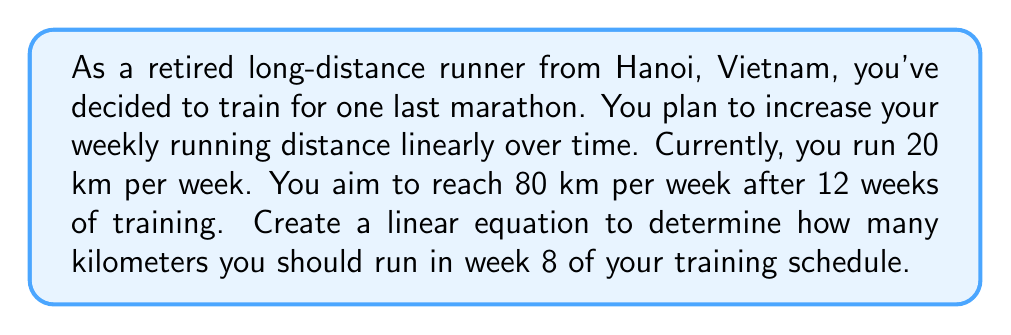Give your solution to this math problem. Let's approach this step-by-step using a linear equation:

1) First, let's define our variables:
   $x$ = number of weeks
   $y$ = distance run in km per week

2) We know two points on this line:
   At week 0: $(0, 20)$
   At week 12: $(12, 80)$

3) We can use the point-slope form of a linear equation:
   $y - y_1 = m(x - x_1)$

4) Calculate the slope $(m)$:
   $m = \frac{y_2 - y_1}{x_2 - x_1} = \frac{80 - 20}{12 - 0} = \frac{60}{12} = 5$

5) Now we can form our equation using the point $(0, 20)$:
   $y - 20 = 5(x - 0)$

6) Simplify:
   $y = 5x + 20$

7) This is our linear equation for the training schedule.

8) To find the distance for week 8, substitute $x = 8$:
   $y = 5(8) + 20$
   $y = 40 + 20$
   $y = 60$

Therefore, in week 8 of your training schedule, you should run 60 km.
Answer: 60 km 